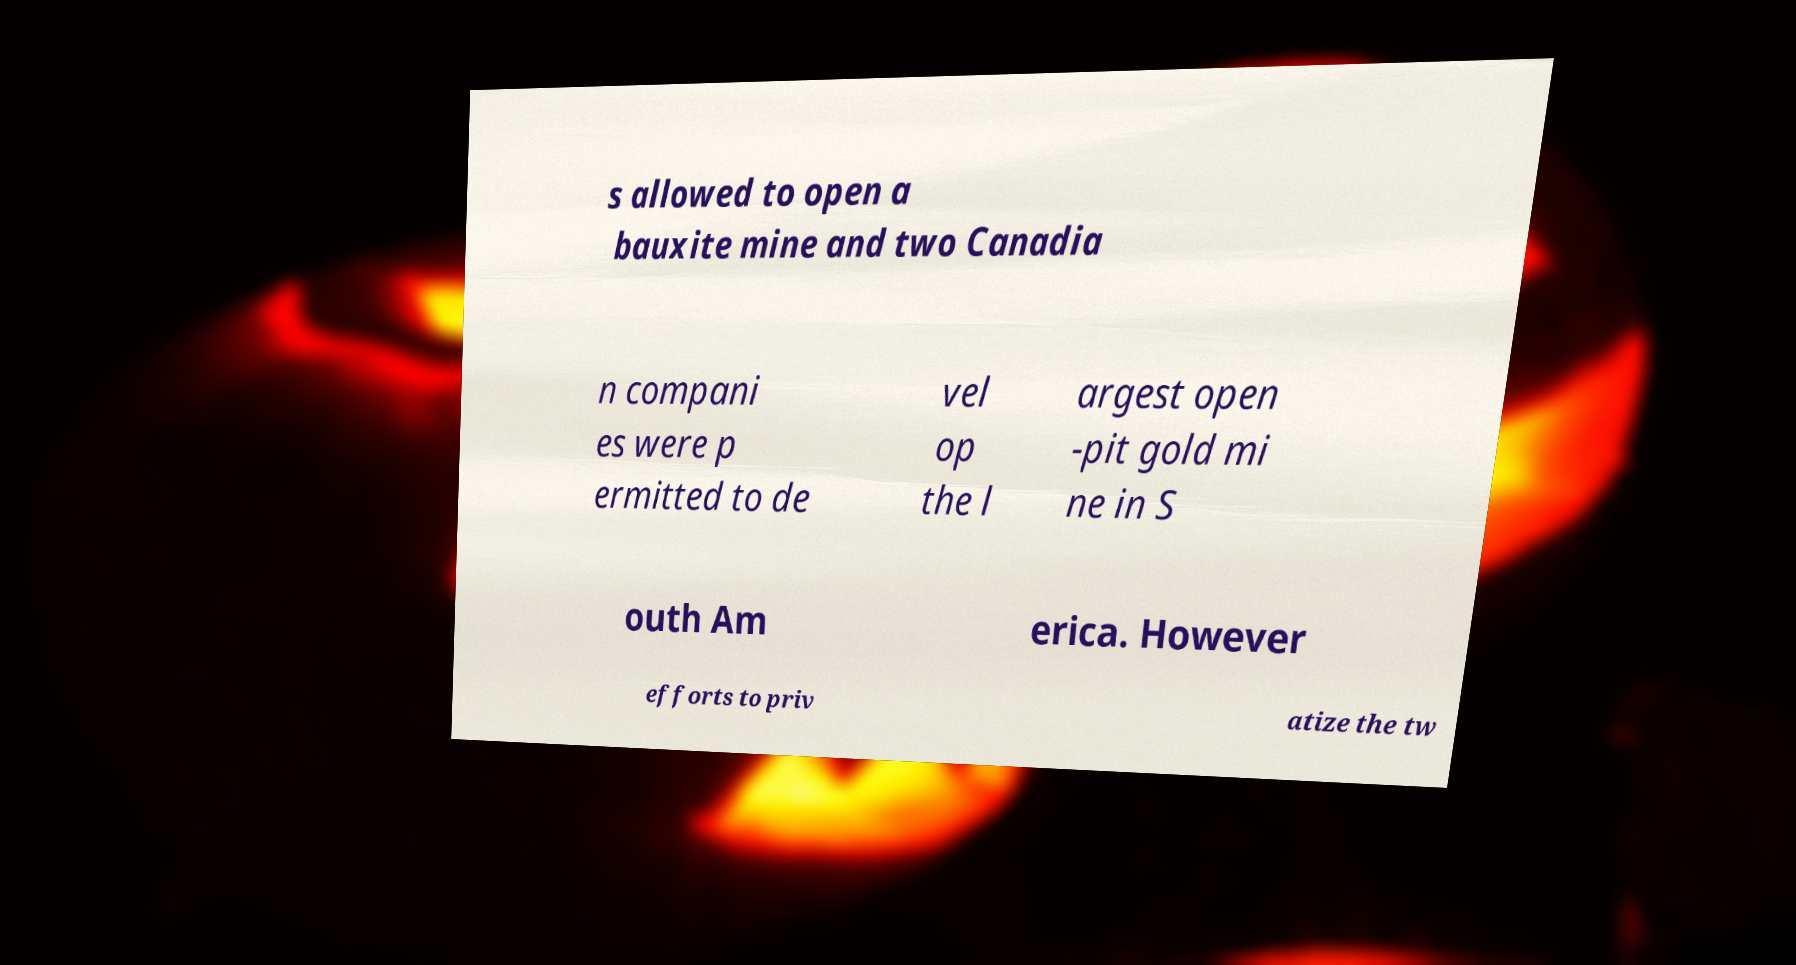I need the written content from this picture converted into text. Can you do that? s allowed to open a bauxite mine and two Canadia n compani es were p ermitted to de vel op the l argest open -pit gold mi ne in S outh Am erica. However efforts to priv atize the tw 